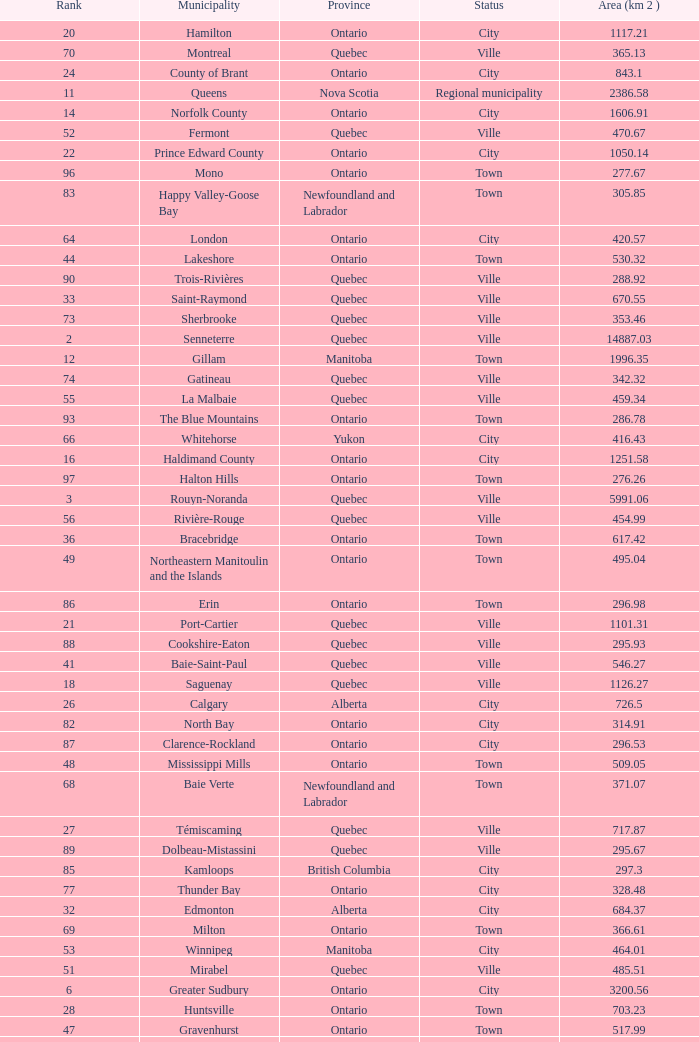What is the listed Status that has the Province of Ontario and Rank of 86? Town. 